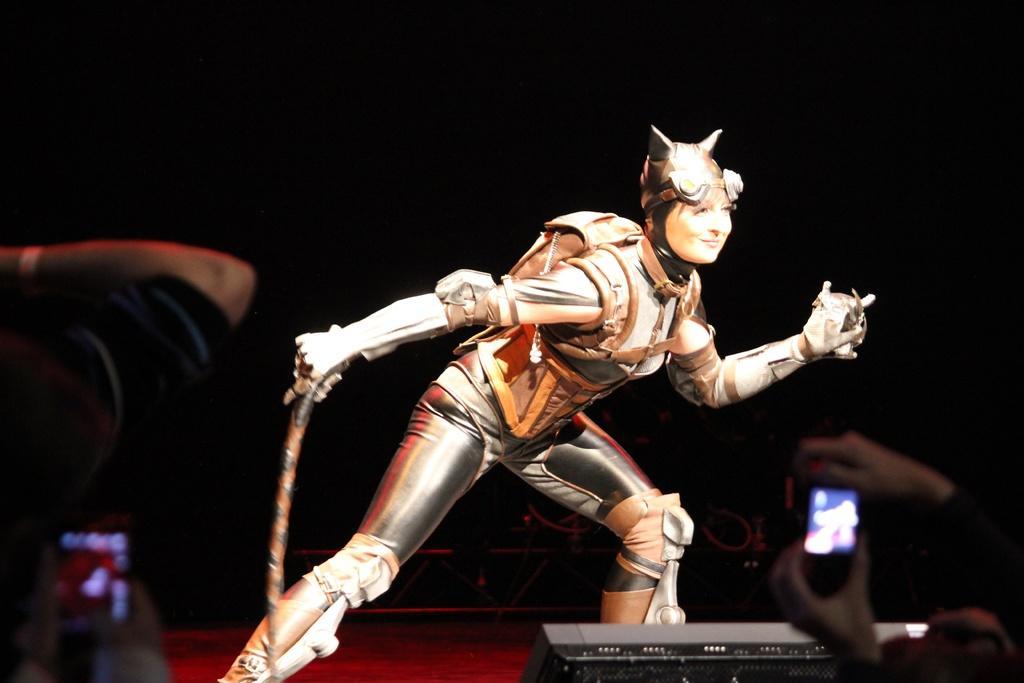Could you give a brief overview of what you see in this image? Here we can see a woman and she is holding a weapon with her hand. She is smiling. Here we can see two persons holding mobile with their hands. There is a dark background. 